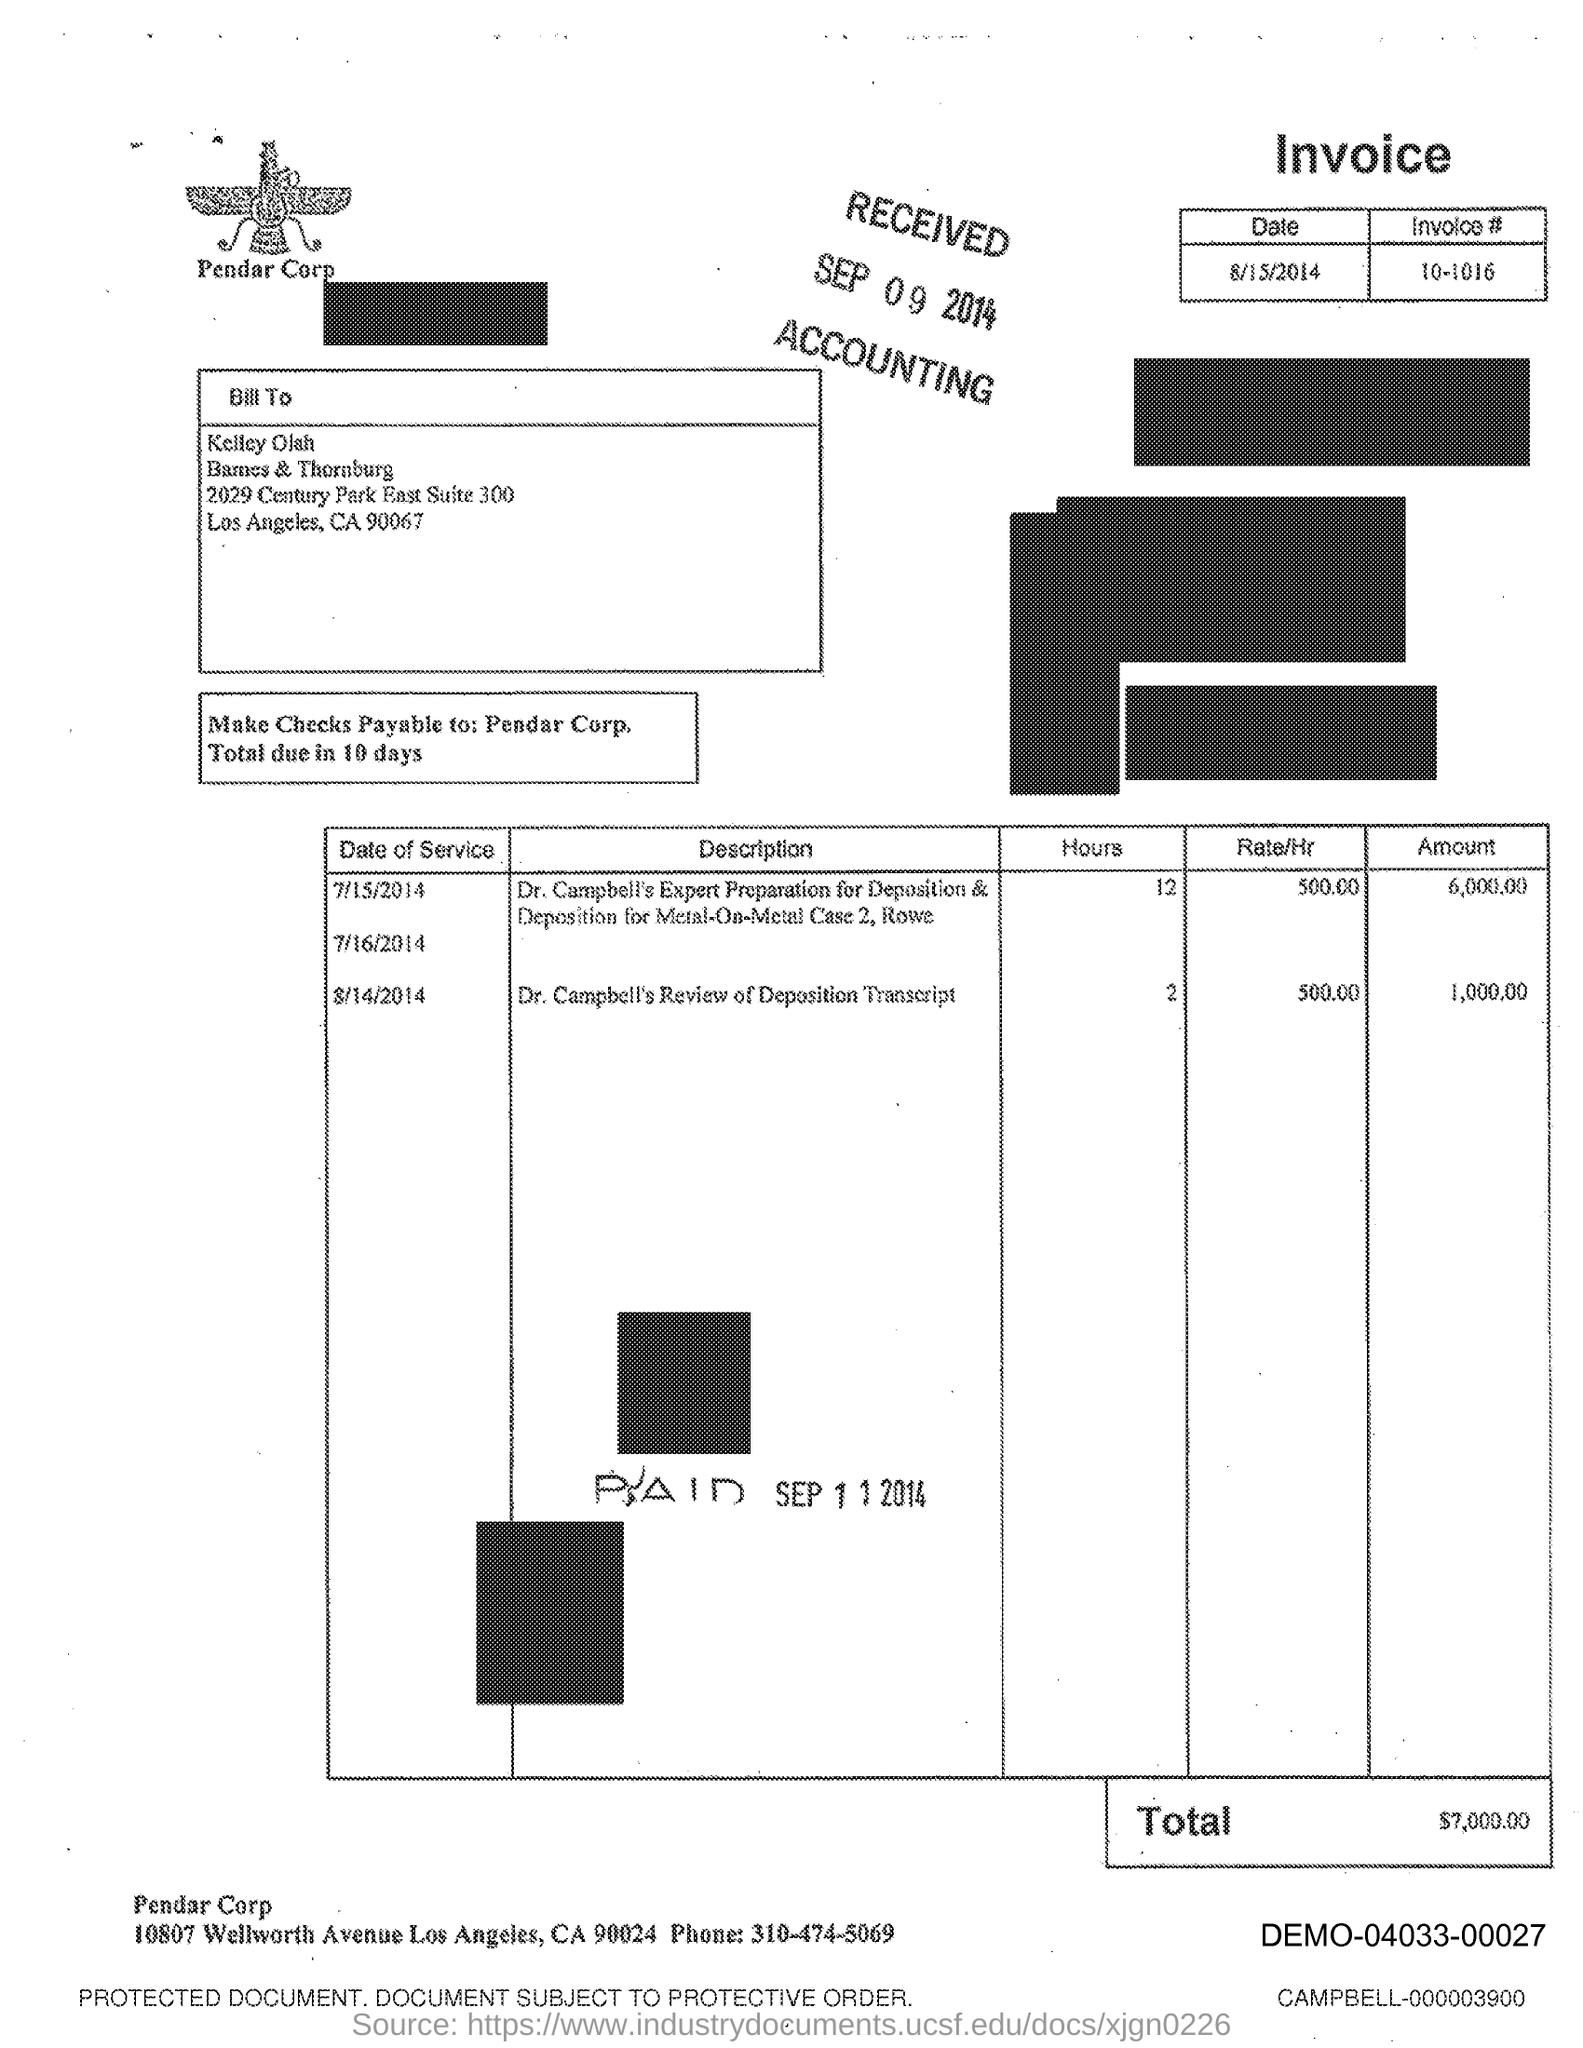What is the time limit for the payment of checks?
Offer a very short reply. 10 days. 